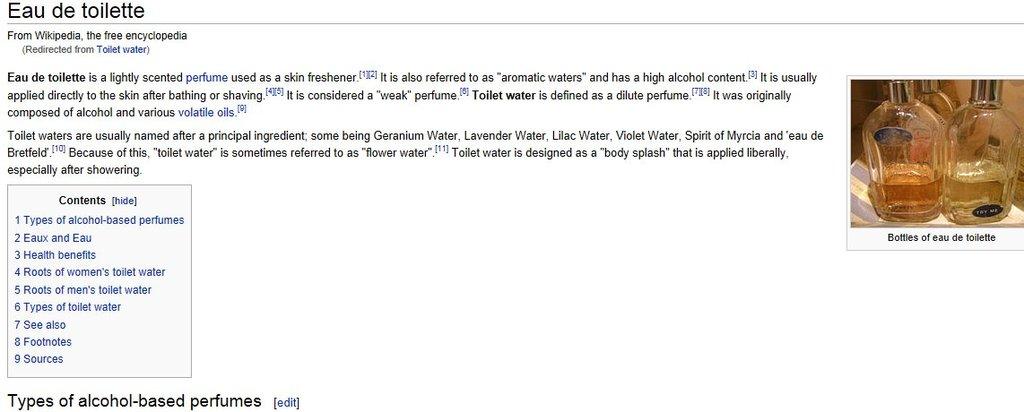What type of perfume is referenced at the bottom of this wikipedia article screenshot?
Offer a terse response. Alcohol based. What does the caption under the photo of perfume say?
Your answer should be compact. Bottles of eau de toilette. 